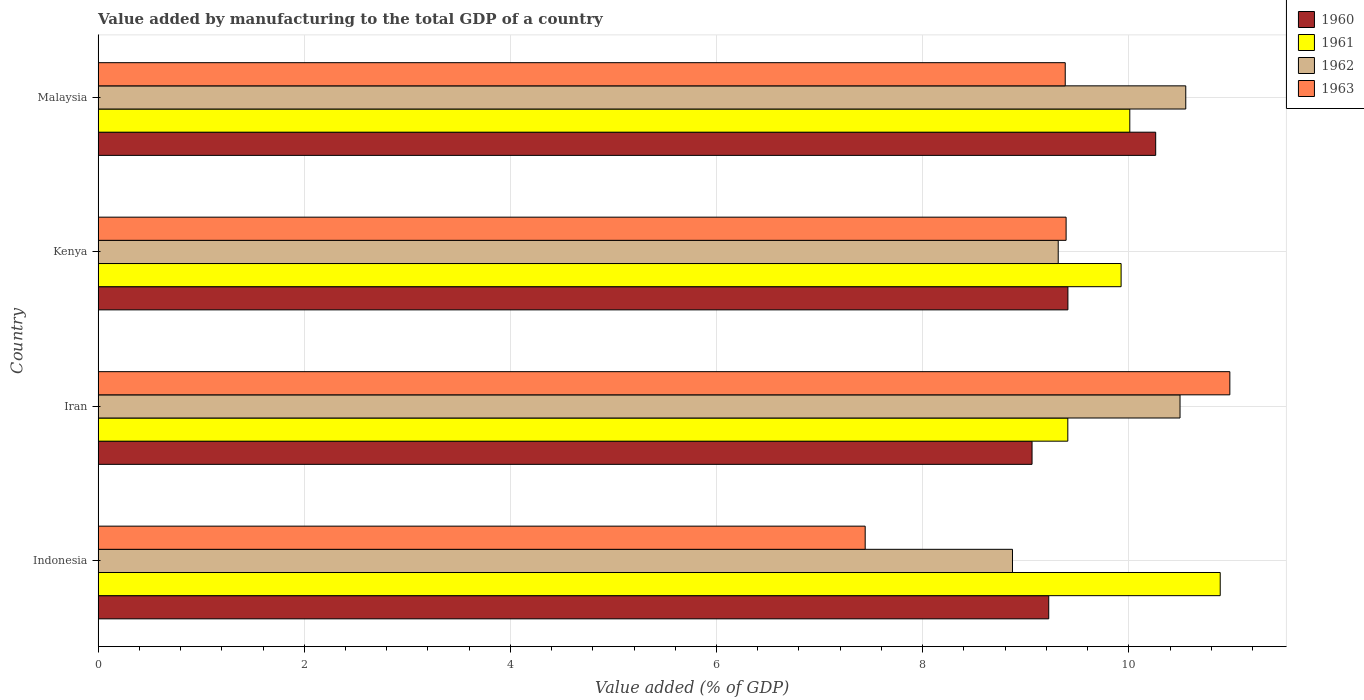How many different coloured bars are there?
Keep it short and to the point. 4. How many groups of bars are there?
Your response must be concise. 4. Are the number of bars per tick equal to the number of legend labels?
Provide a short and direct response. Yes. Are the number of bars on each tick of the Y-axis equal?
Offer a terse response. Yes. How many bars are there on the 1st tick from the bottom?
Offer a very short reply. 4. What is the label of the 1st group of bars from the top?
Your response must be concise. Malaysia. What is the value added by manufacturing to the total GDP in 1960 in Kenya?
Offer a terse response. 9.41. Across all countries, what is the maximum value added by manufacturing to the total GDP in 1961?
Your answer should be compact. 10.89. Across all countries, what is the minimum value added by manufacturing to the total GDP in 1960?
Your answer should be compact. 9.06. In which country was the value added by manufacturing to the total GDP in 1960 minimum?
Offer a very short reply. Iran. What is the total value added by manufacturing to the total GDP in 1962 in the graph?
Provide a short and direct response. 39.24. What is the difference between the value added by manufacturing to the total GDP in 1963 in Iran and that in Malaysia?
Provide a short and direct response. 1.6. What is the difference between the value added by manufacturing to the total GDP in 1963 in Malaysia and the value added by manufacturing to the total GDP in 1960 in Iran?
Your answer should be compact. 0.32. What is the average value added by manufacturing to the total GDP in 1963 per country?
Your answer should be very brief. 9.3. What is the difference between the value added by manufacturing to the total GDP in 1960 and value added by manufacturing to the total GDP in 1963 in Iran?
Your response must be concise. -1.92. In how many countries, is the value added by manufacturing to the total GDP in 1962 greater than 9.6 %?
Give a very brief answer. 2. What is the ratio of the value added by manufacturing to the total GDP in 1962 in Indonesia to that in Iran?
Provide a short and direct response. 0.85. Is the difference between the value added by manufacturing to the total GDP in 1960 in Kenya and Malaysia greater than the difference between the value added by manufacturing to the total GDP in 1963 in Kenya and Malaysia?
Make the answer very short. No. What is the difference between the highest and the second highest value added by manufacturing to the total GDP in 1963?
Provide a succinct answer. 1.59. What is the difference between the highest and the lowest value added by manufacturing to the total GDP in 1961?
Your answer should be very brief. 1.48. What does the 2nd bar from the top in Indonesia represents?
Make the answer very short. 1962. Is it the case that in every country, the sum of the value added by manufacturing to the total GDP in 1961 and value added by manufacturing to the total GDP in 1963 is greater than the value added by manufacturing to the total GDP in 1962?
Offer a very short reply. Yes. Are all the bars in the graph horizontal?
Provide a succinct answer. Yes. Are the values on the major ticks of X-axis written in scientific E-notation?
Ensure brevity in your answer.  No. Does the graph contain grids?
Keep it short and to the point. Yes. Where does the legend appear in the graph?
Ensure brevity in your answer.  Top right. How many legend labels are there?
Ensure brevity in your answer.  4. How are the legend labels stacked?
Make the answer very short. Vertical. What is the title of the graph?
Offer a terse response. Value added by manufacturing to the total GDP of a country. Does "1978" appear as one of the legend labels in the graph?
Keep it short and to the point. No. What is the label or title of the X-axis?
Give a very brief answer. Value added (% of GDP). What is the label or title of the Y-axis?
Ensure brevity in your answer.  Country. What is the Value added (% of GDP) in 1960 in Indonesia?
Your answer should be very brief. 9.22. What is the Value added (% of GDP) in 1961 in Indonesia?
Keep it short and to the point. 10.89. What is the Value added (% of GDP) of 1962 in Indonesia?
Make the answer very short. 8.87. What is the Value added (% of GDP) of 1963 in Indonesia?
Ensure brevity in your answer.  7.44. What is the Value added (% of GDP) in 1960 in Iran?
Provide a short and direct response. 9.06. What is the Value added (% of GDP) of 1961 in Iran?
Give a very brief answer. 9.41. What is the Value added (% of GDP) in 1962 in Iran?
Your response must be concise. 10.5. What is the Value added (% of GDP) of 1963 in Iran?
Keep it short and to the point. 10.98. What is the Value added (% of GDP) of 1960 in Kenya?
Your response must be concise. 9.41. What is the Value added (% of GDP) in 1961 in Kenya?
Offer a terse response. 9.93. What is the Value added (% of GDP) in 1962 in Kenya?
Your answer should be compact. 9.32. What is the Value added (% of GDP) in 1963 in Kenya?
Provide a short and direct response. 9.39. What is the Value added (% of GDP) of 1960 in Malaysia?
Give a very brief answer. 10.26. What is the Value added (% of GDP) in 1961 in Malaysia?
Ensure brevity in your answer.  10.01. What is the Value added (% of GDP) in 1962 in Malaysia?
Your answer should be very brief. 10.55. What is the Value added (% of GDP) in 1963 in Malaysia?
Keep it short and to the point. 9.38. Across all countries, what is the maximum Value added (% of GDP) of 1960?
Provide a succinct answer. 10.26. Across all countries, what is the maximum Value added (% of GDP) of 1961?
Offer a terse response. 10.89. Across all countries, what is the maximum Value added (% of GDP) of 1962?
Your response must be concise. 10.55. Across all countries, what is the maximum Value added (% of GDP) in 1963?
Your answer should be very brief. 10.98. Across all countries, what is the minimum Value added (% of GDP) of 1960?
Make the answer very short. 9.06. Across all countries, what is the minimum Value added (% of GDP) of 1961?
Give a very brief answer. 9.41. Across all countries, what is the minimum Value added (% of GDP) in 1962?
Provide a succinct answer. 8.87. Across all countries, what is the minimum Value added (% of GDP) in 1963?
Your response must be concise. 7.44. What is the total Value added (% of GDP) in 1960 in the graph?
Your answer should be compact. 37.95. What is the total Value added (% of GDP) in 1961 in the graph?
Your answer should be very brief. 40.23. What is the total Value added (% of GDP) in 1962 in the graph?
Ensure brevity in your answer.  39.24. What is the total Value added (% of GDP) in 1963 in the graph?
Make the answer very short. 37.2. What is the difference between the Value added (% of GDP) in 1960 in Indonesia and that in Iran?
Your response must be concise. 0.16. What is the difference between the Value added (% of GDP) in 1961 in Indonesia and that in Iran?
Ensure brevity in your answer.  1.48. What is the difference between the Value added (% of GDP) in 1962 in Indonesia and that in Iran?
Give a very brief answer. -1.63. What is the difference between the Value added (% of GDP) of 1963 in Indonesia and that in Iran?
Keep it short and to the point. -3.54. What is the difference between the Value added (% of GDP) in 1960 in Indonesia and that in Kenya?
Your answer should be very brief. -0.19. What is the difference between the Value added (% of GDP) in 1961 in Indonesia and that in Kenya?
Provide a short and direct response. 0.96. What is the difference between the Value added (% of GDP) in 1962 in Indonesia and that in Kenya?
Your response must be concise. -0.44. What is the difference between the Value added (% of GDP) in 1963 in Indonesia and that in Kenya?
Offer a very short reply. -1.95. What is the difference between the Value added (% of GDP) in 1960 in Indonesia and that in Malaysia?
Your answer should be compact. -1.04. What is the difference between the Value added (% of GDP) of 1961 in Indonesia and that in Malaysia?
Ensure brevity in your answer.  0.88. What is the difference between the Value added (% of GDP) of 1962 in Indonesia and that in Malaysia?
Your answer should be compact. -1.68. What is the difference between the Value added (% of GDP) in 1963 in Indonesia and that in Malaysia?
Offer a very short reply. -1.94. What is the difference between the Value added (% of GDP) in 1960 in Iran and that in Kenya?
Offer a very short reply. -0.35. What is the difference between the Value added (% of GDP) in 1961 in Iran and that in Kenya?
Your answer should be compact. -0.52. What is the difference between the Value added (% of GDP) in 1962 in Iran and that in Kenya?
Provide a succinct answer. 1.18. What is the difference between the Value added (% of GDP) of 1963 in Iran and that in Kenya?
Make the answer very short. 1.59. What is the difference between the Value added (% of GDP) of 1960 in Iran and that in Malaysia?
Offer a very short reply. -1.2. What is the difference between the Value added (% of GDP) of 1961 in Iran and that in Malaysia?
Provide a short and direct response. -0.6. What is the difference between the Value added (% of GDP) in 1962 in Iran and that in Malaysia?
Make the answer very short. -0.06. What is the difference between the Value added (% of GDP) in 1963 in Iran and that in Malaysia?
Your answer should be very brief. 1.6. What is the difference between the Value added (% of GDP) in 1960 in Kenya and that in Malaysia?
Ensure brevity in your answer.  -0.85. What is the difference between the Value added (% of GDP) of 1961 in Kenya and that in Malaysia?
Give a very brief answer. -0.08. What is the difference between the Value added (% of GDP) of 1962 in Kenya and that in Malaysia?
Provide a succinct answer. -1.24. What is the difference between the Value added (% of GDP) of 1963 in Kenya and that in Malaysia?
Your answer should be compact. 0.01. What is the difference between the Value added (% of GDP) of 1960 in Indonesia and the Value added (% of GDP) of 1961 in Iran?
Keep it short and to the point. -0.18. What is the difference between the Value added (% of GDP) of 1960 in Indonesia and the Value added (% of GDP) of 1962 in Iran?
Offer a terse response. -1.27. What is the difference between the Value added (% of GDP) in 1960 in Indonesia and the Value added (% of GDP) in 1963 in Iran?
Ensure brevity in your answer.  -1.76. What is the difference between the Value added (% of GDP) in 1961 in Indonesia and the Value added (% of GDP) in 1962 in Iran?
Give a very brief answer. 0.39. What is the difference between the Value added (% of GDP) of 1961 in Indonesia and the Value added (% of GDP) of 1963 in Iran?
Make the answer very short. -0.09. What is the difference between the Value added (% of GDP) in 1962 in Indonesia and the Value added (% of GDP) in 1963 in Iran?
Give a very brief answer. -2.11. What is the difference between the Value added (% of GDP) in 1960 in Indonesia and the Value added (% of GDP) in 1961 in Kenya?
Keep it short and to the point. -0.7. What is the difference between the Value added (% of GDP) of 1960 in Indonesia and the Value added (% of GDP) of 1962 in Kenya?
Provide a short and direct response. -0.09. What is the difference between the Value added (% of GDP) of 1960 in Indonesia and the Value added (% of GDP) of 1963 in Kenya?
Your answer should be compact. -0.17. What is the difference between the Value added (% of GDP) of 1961 in Indonesia and the Value added (% of GDP) of 1962 in Kenya?
Make the answer very short. 1.57. What is the difference between the Value added (% of GDP) in 1961 in Indonesia and the Value added (% of GDP) in 1963 in Kenya?
Your response must be concise. 1.5. What is the difference between the Value added (% of GDP) of 1962 in Indonesia and the Value added (% of GDP) of 1963 in Kenya?
Ensure brevity in your answer.  -0.52. What is the difference between the Value added (% of GDP) in 1960 in Indonesia and the Value added (% of GDP) in 1961 in Malaysia?
Ensure brevity in your answer.  -0.79. What is the difference between the Value added (% of GDP) of 1960 in Indonesia and the Value added (% of GDP) of 1962 in Malaysia?
Provide a short and direct response. -1.33. What is the difference between the Value added (% of GDP) of 1960 in Indonesia and the Value added (% of GDP) of 1963 in Malaysia?
Offer a very short reply. -0.16. What is the difference between the Value added (% of GDP) of 1961 in Indonesia and the Value added (% of GDP) of 1962 in Malaysia?
Offer a very short reply. 0.33. What is the difference between the Value added (% of GDP) in 1961 in Indonesia and the Value added (% of GDP) in 1963 in Malaysia?
Keep it short and to the point. 1.5. What is the difference between the Value added (% of GDP) in 1962 in Indonesia and the Value added (% of GDP) in 1963 in Malaysia?
Offer a very short reply. -0.51. What is the difference between the Value added (% of GDP) in 1960 in Iran and the Value added (% of GDP) in 1961 in Kenya?
Ensure brevity in your answer.  -0.86. What is the difference between the Value added (% of GDP) in 1960 in Iran and the Value added (% of GDP) in 1962 in Kenya?
Your answer should be compact. -0.25. What is the difference between the Value added (% of GDP) of 1960 in Iran and the Value added (% of GDP) of 1963 in Kenya?
Your response must be concise. -0.33. What is the difference between the Value added (% of GDP) in 1961 in Iran and the Value added (% of GDP) in 1962 in Kenya?
Make the answer very short. 0.09. What is the difference between the Value added (% of GDP) in 1961 in Iran and the Value added (% of GDP) in 1963 in Kenya?
Keep it short and to the point. 0.02. What is the difference between the Value added (% of GDP) of 1962 in Iran and the Value added (% of GDP) of 1963 in Kenya?
Keep it short and to the point. 1.11. What is the difference between the Value added (% of GDP) of 1960 in Iran and the Value added (% of GDP) of 1961 in Malaysia?
Offer a very short reply. -0.95. What is the difference between the Value added (% of GDP) of 1960 in Iran and the Value added (% of GDP) of 1962 in Malaysia?
Ensure brevity in your answer.  -1.49. What is the difference between the Value added (% of GDP) of 1960 in Iran and the Value added (% of GDP) of 1963 in Malaysia?
Ensure brevity in your answer.  -0.32. What is the difference between the Value added (% of GDP) in 1961 in Iran and the Value added (% of GDP) in 1962 in Malaysia?
Provide a short and direct response. -1.14. What is the difference between the Value added (% of GDP) of 1961 in Iran and the Value added (% of GDP) of 1963 in Malaysia?
Offer a very short reply. 0.03. What is the difference between the Value added (% of GDP) of 1962 in Iran and the Value added (% of GDP) of 1963 in Malaysia?
Provide a short and direct response. 1.11. What is the difference between the Value added (% of GDP) in 1960 in Kenya and the Value added (% of GDP) in 1961 in Malaysia?
Your answer should be compact. -0.6. What is the difference between the Value added (% of GDP) of 1960 in Kenya and the Value added (% of GDP) of 1962 in Malaysia?
Keep it short and to the point. -1.14. What is the difference between the Value added (% of GDP) of 1960 in Kenya and the Value added (% of GDP) of 1963 in Malaysia?
Your response must be concise. 0.03. What is the difference between the Value added (% of GDP) of 1961 in Kenya and the Value added (% of GDP) of 1962 in Malaysia?
Offer a terse response. -0.63. What is the difference between the Value added (% of GDP) of 1961 in Kenya and the Value added (% of GDP) of 1963 in Malaysia?
Make the answer very short. 0.54. What is the difference between the Value added (% of GDP) of 1962 in Kenya and the Value added (% of GDP) of 1963 in Malaysia?
Offer a terse response. -0.07. What is the average Value added (% of GDP) of 1960 per country?
Ensure brevity in your answer.  9.49. What is the average Value added (% of GDP) of 1961 per country?
Keep it short and to the point. 10.06. What is the average Value added (% of GDP) of 1962 per country?
Make the answer very short. 9.81. What is the average Value added (% of GDP) of 1963 per country?
Provide a short and direct response. 9.3. What is the difference between the Value added (% of GDP) in 1960 and Value added (% of GDP) in 1961 in Indonesia?
Your response must be concise. -1.66. What is the difference between the Value added (% of GDP) of 1960 and Value added (% of GDP) of 1962 in Indonesia?
Give a very brief answer. 0.35. What is the difference between the Value added (% of GDP) of 1960 and Value added (% of GDP) of 1963 in Indonesia?
Keep it short and to the point. 1.78. What is the difference between the Value added (% of GDP) of 1961 and Value added (% of GDP) of 1962 in Indonesia?
Make the answer very short. 2.02. What is the difference between the Value added (% of GDP) of 1961 and Value added (% of GDP) of 1963 in Indonesia?
Ensure brevity in your answer.  3.44. What is the difference between the Value added (% of GDP) of 1962 and Value added (% of GDP) of 1963 in Indonesia?
Offer a very short reply. 1.43. What is the difference between the Value added (% of GDP) in 1960 and Value added (% of GDP) in 1961 in Iran?
Your answer should be very brief. -0.35. What is the difference between the Value added (% of GDP) of 1960 and Value added (% of GDP) of 1962 in Iran?
Your answer should be very brief. -1.44. What is the difference between the Value added (% of GDP) in 1960 and Value added (% of GDP) in 1963 in Iran?
Keep it short and to the point. -1.92. What is the difference between the Value added (% of GDP) in 1961 and Value added (% of GDP) in 1962 in Iran?
Make the answer very short. -1.09. What is the difference between the Value added (% of GDP) in 1961 and Value added (% of GDP) in 1963 in Iran?
Provide a succinct answer. -1.57. What is the difference between the Value added (% of GDP) of 1962 and Value added (% of GDP) of 1963 in Iran?
Give a very brief answer. -0.48. What is the difference between the Value added (% of GDP) of 1960 and Value added (% of GDP) of 1961 in Kenya?
Your answer should be very brief. -0.52. What is the difference between the Value added (% of GDP) of 1960 and Value added (% of GDP) of 1962 in Kenya?
Provide a short and direct response. 0.09. What is the difference between the Value added (% of GDP) of 1960 and Value added (% of GDP) of 1963 in Kenya?
Offer a terse response. 0.02. What is the difference between the Value added (% of GDP) in 1961 and Value added (% of GDP) in 1962 in Kenya?
Your answer should be compact. 0.61. What is the difference between the Value added (% of GDP) in 1961 and Value added (% of GDP) in 1963 in Kenya?
Your answer should be very brief. 0.53. What is the difference between the Value added (% of GDP) in 1962 and Value added (% of GDP) in 1963 in Kenya?
Your response must be concise. -0.08. What is the difference between the Value added (% of GDP) of 1960 and Value added (% of GDP) of 1961 in Malaysia?
Offer a terse response. 0.25. What is the difference between the Value added (% of GDP) in 1960 and Value added (% of GDP) in 1962 in Malaysia?
Keep it short and to the point. -0.29. What is the difference between the Value added (% of GDP) in 1960 and Value added (% of GDP) in 1963 in Malaysia?
Keep it short and to the point. 0.88. What is the difference between the Value added (% of GDP) of 1961 and Value added (% of GDP) of 1962 in Malaysia?
Your response must be concise. -0.54. What is the difference between the Value added (% of GDP) in 1961 and Value added (% of GDP) in 1963 in Malaysia?
Offer a very short reply. 0.63. What is the difference between the Value added (% of GDP) in 1962 and Value added (% of GDP) in 1963 in Malaysia?
Your answer should be compact. 1.17. What is the ratio of the Value added (% of GDP) in 1960 in Indonesia to that in Iran?
Your answer should be compact. 1.02. What is the ratio of the Value added (% of GDP) in 1961 in Indonesia to that in Iran?
Provide a succinct answer. 1.16. What is the ratio of the Value added (% of GDP) in 1962 in Indonesia to that in Iran?
Provide a succinct answer. 0.85. What is the ratio of the Value added (% of GDP) of 1963 in Indonesia to that in Iran?
Your answer should be compact. 0.68. What is the ratio of the Value added (% of GDP) in 1960 in Indonesia to that in Kenya?
Provide a short and direct response. 0.98. What is the ratio of the Value added (% of GDP) in 1961 in Indonesia to that in Kenya?
Provide a succinct answer. 1.1. What is the ratio of the Value added (% of GDP) in 1962 in Indonesia to that in Kenya?
Keep it short and to the point. 0.95. What is the ratio of the Value added (% of GDP) in 1963 in Indonesia to that in Kenya?
Your response must be concise. 0.79. What is the ratio of the Value added (% of GDP) in 1960 in Indonesia to that in Malaysia?
Make the answer very short. 0.9. What is the ratio of the Value added (% of GDP) of 1961 in Indonesia to that in Malaysia?
Make the answer very short. 1.09. What is the ratio of the Value added (% of GDP) in 1962 in Indonesia to that in Malaysia?
Your response must be concise. 0.84. What is the ratio of the Value added (% of GDP) of 1963 in Indonesia to that in Malaysia?
Provide a short and direct response. 0.79. What is the ratio of the Value added (% of GDP) in 1960 in Iran to that in Kenya?
Ensure brevity in your answer.  0.96. What is the ratio of the Value added (% of GDP) of 1961 in Iran to that in Kenya?
Offer a terse response. 0.95. What is the ratio of the Value added (% of GDP) of 1962 in Iran to that in Kenya?
Provide a short and direct response. 1.13. What is the ratio of the Value added (% of GDP) of 1963 in Iran to that in Kenya?
Make the answer very short. 1.17. What is the ratio of the Value added (% of GDP) in 1960 in Iran to that in Malaysia?
Your answer should be very brief. 0.88. What is the ratio of the Value added (% of GDP) of 1961 in Iran to that in Malaysia?
Offer a terse response. 0.94. What is the ratio of the Value added (% of GDP) of 1962 in Iran to that in Malaysia?
Your response must be concise. 0.99. What is the ratio of the Value added (% of GDP) in 1963 in Iran to that in Malaysia?
Ensure brevity in your answer.  1.17. What is the ratio of the Value added (% of GDP) of 1960 in Kenya to that in Malaysia?
Provide a short and direct response. 0.92. What is the ratio of the Value added (% of GDP) of 1961 in Kenya to that in Malaysia?
Your response must be concise. 0.99. What is the ratio of the Value added (% of GDP) of 1962 in Kenya to that in Malaysia?
Provide a succinct answer. 0.88. What is the difference between the highest and the second highest Value added (% of GDP) of 1960?
Give a very brief answer. 0.85. What is the difference between the highest and the second highest Value added (% of GDP) in 1961?
Provide a short and direct response. 0.88. What is the difference between the highest and the second highest Value added (% of GDP) in 1962?
Make the answer very short. 0.06. What is the difference between the highest and the second highest Value added (% of GDP) of 1963?
Make the answer very short. 1.59. What is the difference between the highest and the lowest Value added (% of GDP) of 1960?
Your response must be concise. 1.2. What is the difference between the highest and the lowest Value added (% of GDP) of 1961?
Your answer should be compact. 1.48. What is the difference between the highest and the lowest Value added (% of GDP) of 1962?
Your answer should be very brief. 1.68. What is the difference between the highest and the lowest Value added (% of GDP) in 1963?
Your answer should be very brief. 3.54. 